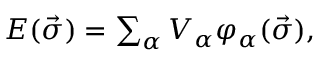Convert formula to latex. <formula><loc_0><loc_0><loc_500><loc_500>\begin{array} { r } { E ( \vec { \sigma } ) = \sum _ { \alpha } V _ { \alpha } \varphi _ { \alpha } ( \vec { \sigma } ) , } \end{array}</formula> 